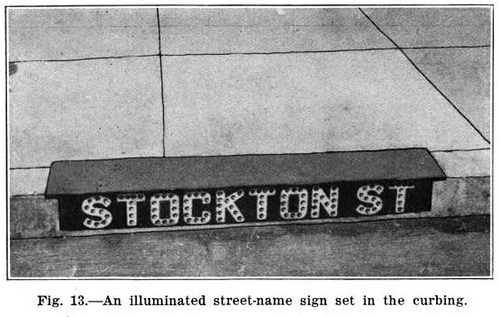Describe the objects in this image and their specific colors. I can see various objects in this image with different colors. 